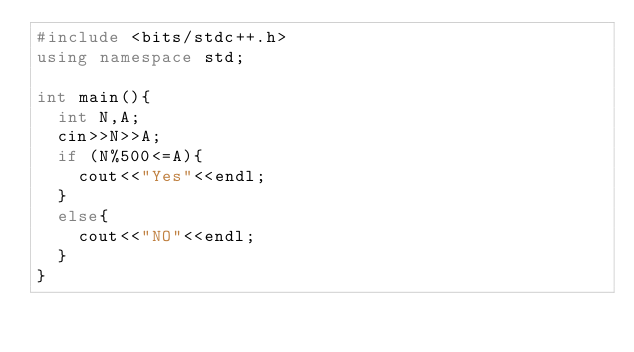Convert code to text. <code><loc_0><loc_0><loc_500><loc_500><_C++_>#include <bits/stdc++.h>
using namespace std;

int main(){
  int N,A;
  cin>>N>>A;
  if (N%500<=A){
    cout<<"Yes"<<endl;
  }
  else{
    cout<<"NO"<<endl;
  }
}</code> 